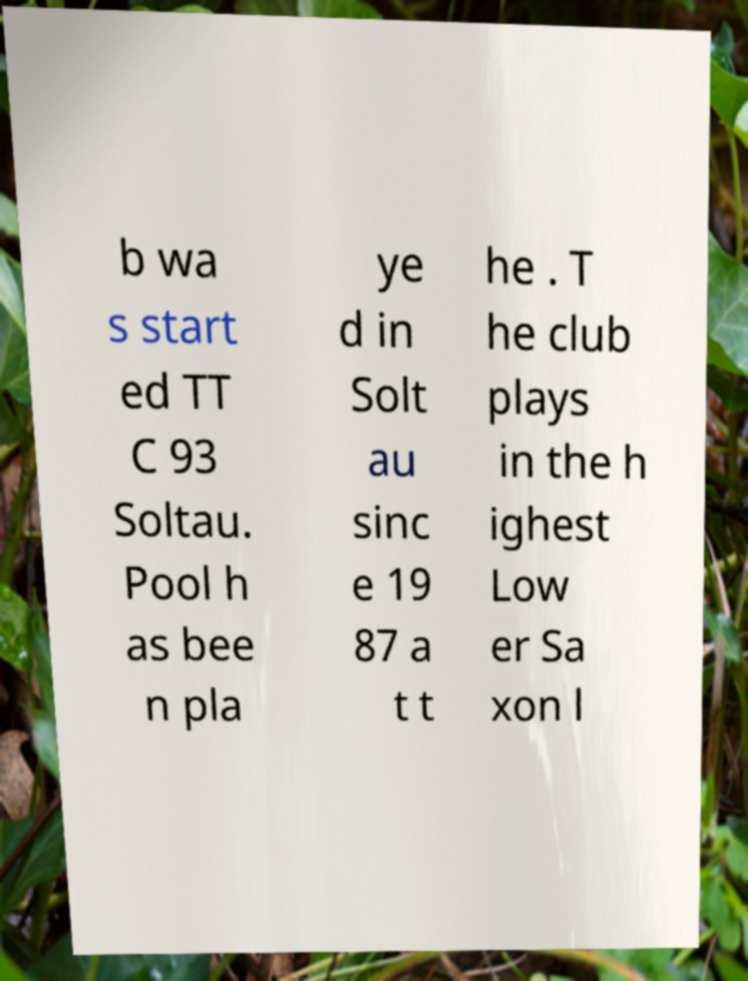Could you assist in decoding the text presented in this image and type it out clearly? b wa s start ed TT C 93 Soltau. Pool h as bee n pla ye d in Solt au sinc e 19 87 a t t he . T he club plays in the h ighest Low er Sa xon l 